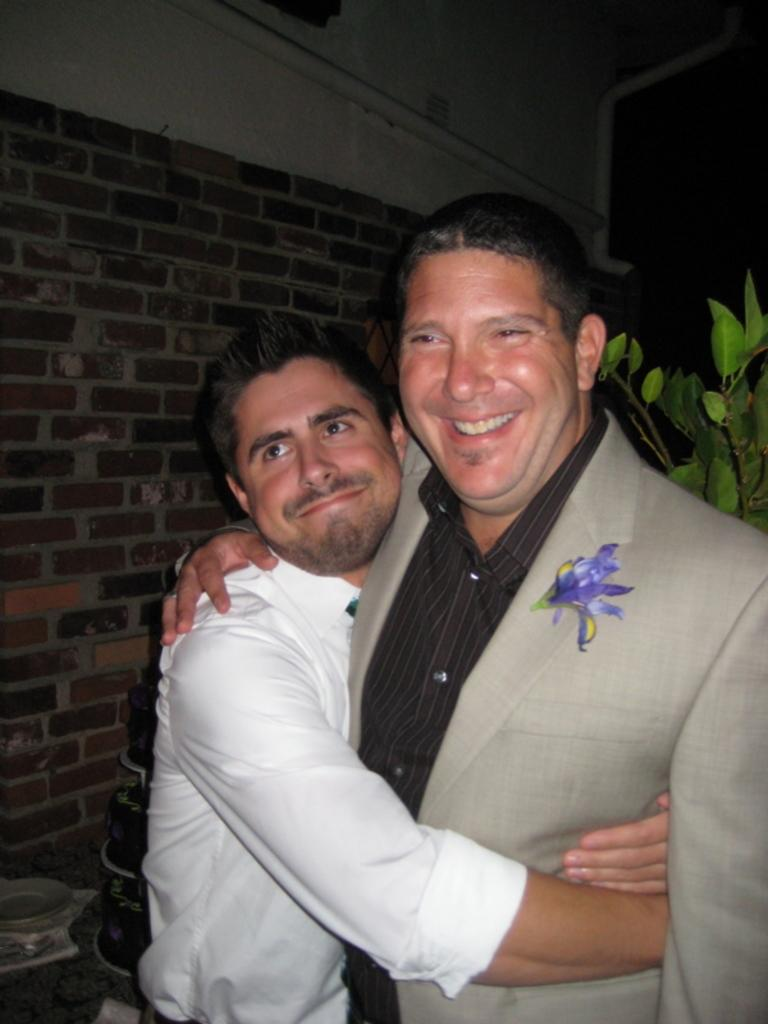How many people are in the image? There are two men in the image. What are the men doing in the image? The men are standing and hugging. What can be seen in the background of the image? There is a green color plant and a brick wall in the background of the image. Is there any quicksand visible in the image? No, there is no quicksand present in the image. Can you tell me what type of button the judge is wearing in the image? There is no judge or button present in the image. 